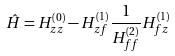<formula> <loc_0><loc_0><loc_500><loc_500>\hat { H } = H _ { z z } ^ { \left ( 0 \right ) } - H _ { z f } ^ { ( 1 ) } \frac { 1 } { H _ { f f } ^ { ( 2 ) } } H _ { f z } ^ { \left ( 1 \right ) }</formula> 